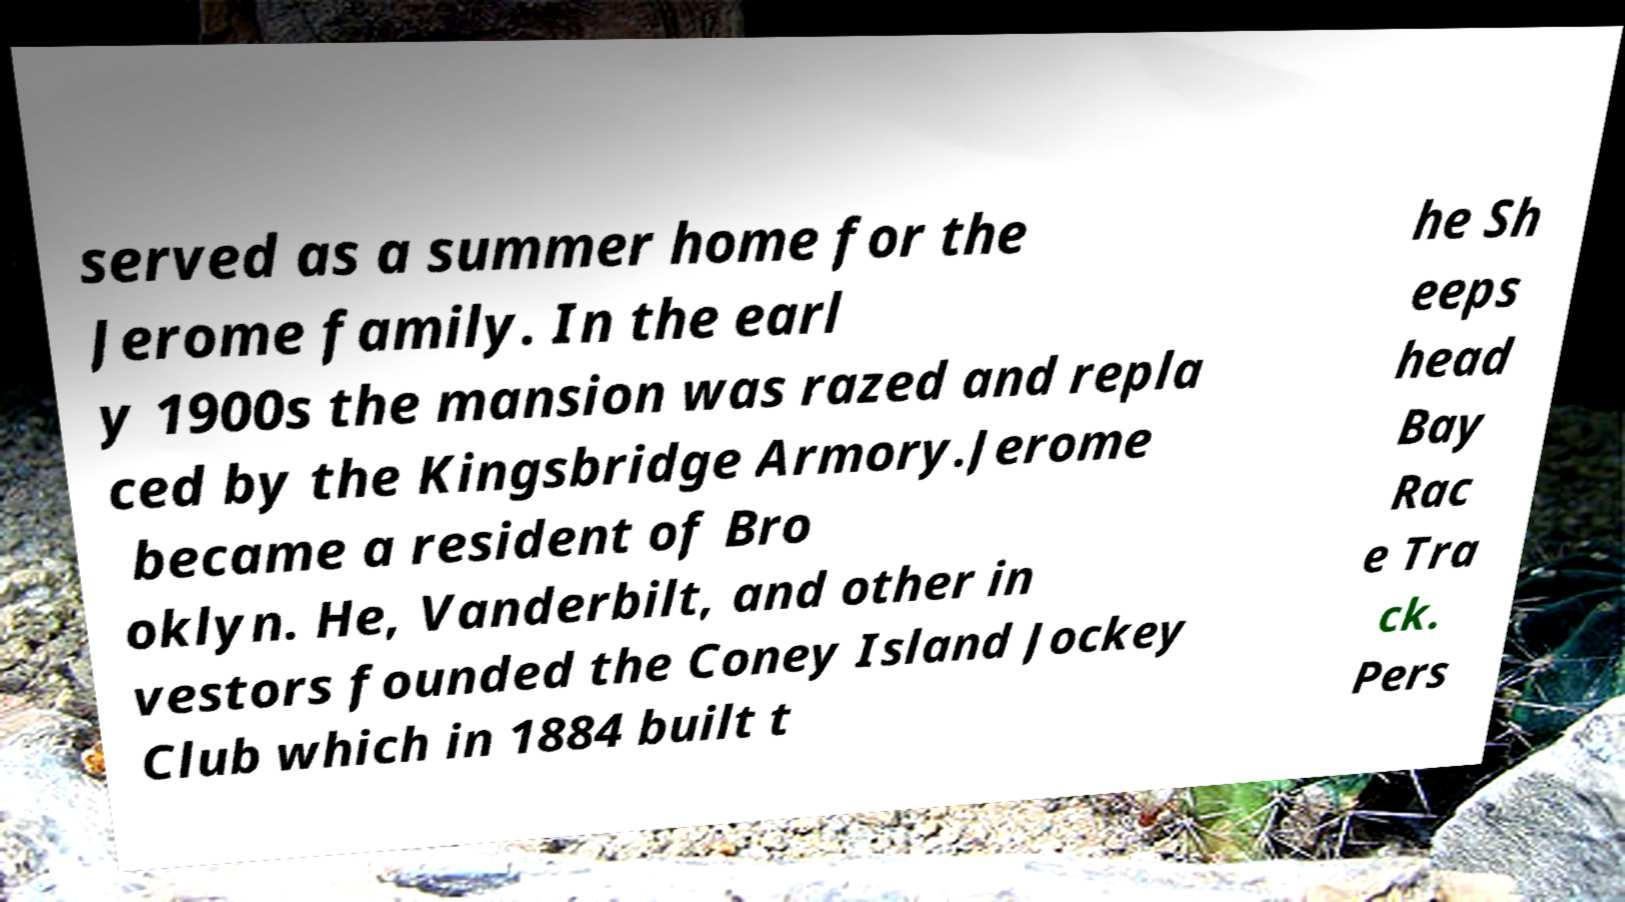Could you extract and type out the text from this image? served as a summer home for the Jerome family. In the earl y 1900s the mansion was razed and repla ced by the Kingsbridge Armory.Jerome became a resident of Bro oklyn. He, Vanderbilt, and other in vestors founded the Coney Island Jockey Club which in 1884 built t he Sh eeps head Bay Rac e Tra ck. Pers 